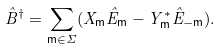Convert formula to latex. <formula><loc_0><loc_0><loc_500><loc_500>\hat { B } ^ { \dagger } = \sum _ { { \mathsf m } \in \Sigma } ( X _ { \mathsf m } \hat { E } _ { \mathsf m } - Y _ { \mathsf m } ^ { * } \hat { E } _ { - { \mathsf m } } ) .</formula> 